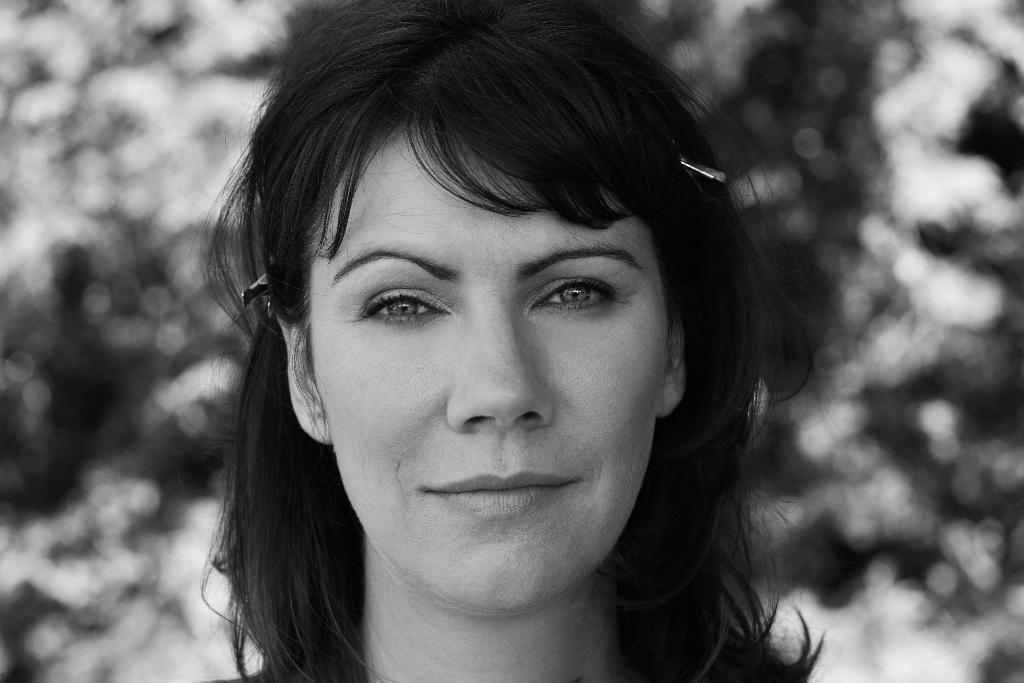What is the main subject of the image? The main subject of the image is the face of a woman. What color scheme is used in the image? The image is in black and white color. What type of government is depicted in the image? There is no depiction of a government in the image; it features the face of a woman in black and white. Can you see a snail crawling on the woman's face in the image? There is no snail present in the image; it only features the face of a woman in black and white. 